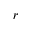Convert formula to latex. <formula><loc_0><loc_0><loc_500><loc_500>r</formula> 